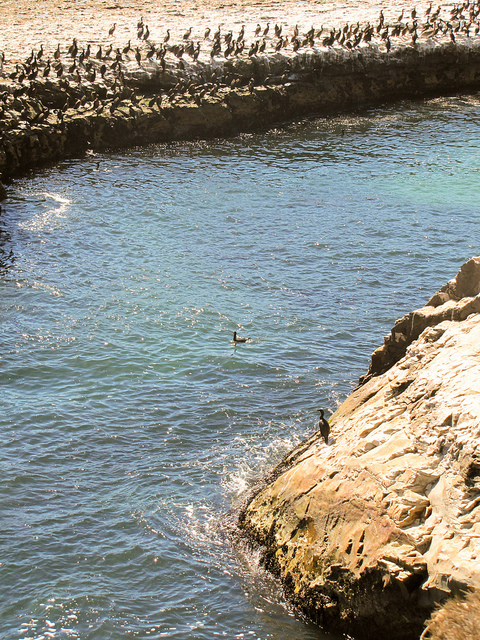What surface are all the birds standing on next to the big river?
A. wood
B. grass
C. stone
D. dirt The birds are standing on a jagged stone surface which forms a natural barrier next to a large body of water. Their perching on the stone brings to mind the sturdy and enduring qualities of this natural material, which resists the persistent ebb and flow of the water beside it. 